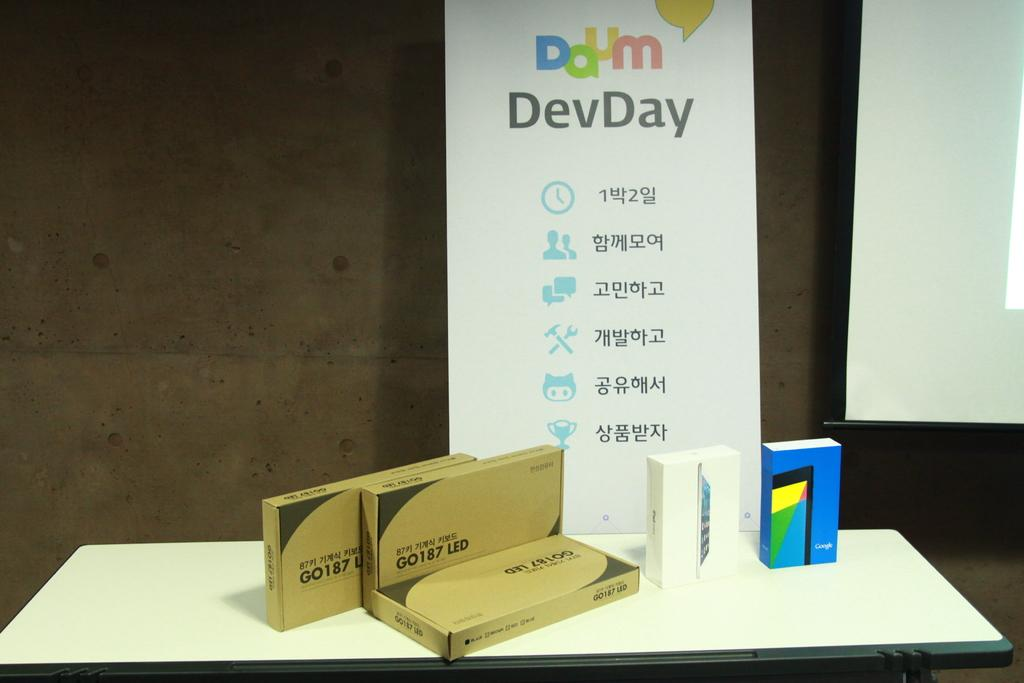<image>
Relay a brief, clear account of the picture shown. A sign with foreign writing and DevDay written at the top 